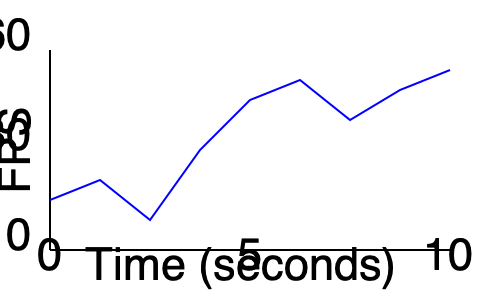Analizando el gráfico de rendimiento del motor de juegos, ¿qué patrón se observa en la tasa de fotogramas por segundo (FPS) a lo largo del tiempo y qué podría indicar esto sobre el rendimiento del juego? Para analizar el patrón en la tasa de fotogramas por segundo (FPS), seguiremos estos pasos:

1. Observar la tendencia general:
   - La línea comienza alrededor de 25 FPS y termina cerca de 55 FPS.
   - Esto indica una tendencia general ascendente en el rendimiento.

2. Identificar fluctuaciones:
   - Hay varios picos y valles en la línea.
   - Esto sugiere que el rendimiento no es constante y varía a lo largo del tiempo.

3. Analizar la magnitud de las fluctuaciones:
   - Las fluctuaciones son significativas, con cambios de hasta 30 FPS en cortos períodos.
   - Esto indica inestabilidad en el rendimiento del juego.

4. Examinar la frecuencia de las fluctuaciones:
   - Las fluctuaciones ocurren aproximadamente cada 1-2 segundos.
   - Esto podría indicar problemas recurrentes o carga de recursos cíclica.

5. Interpretar el patrón:
   - El patrón muestra una mejora general del rendimiento con inestabilidad.
   - Esto sugiere que aunque el motor está optimizando gradualmente, hay problemas que causan caídas de FPS periódicas.

Conclusión: El patrón observado es de mejora general con fluctuaciones frecuentes y significativas, lo que indica un rendimiento inestable del motor de juegos que requiere optimización adicional para suavizar las caídas de FPS.
Answer: Mejora general con fluctuaciones frecuentes y significativas 